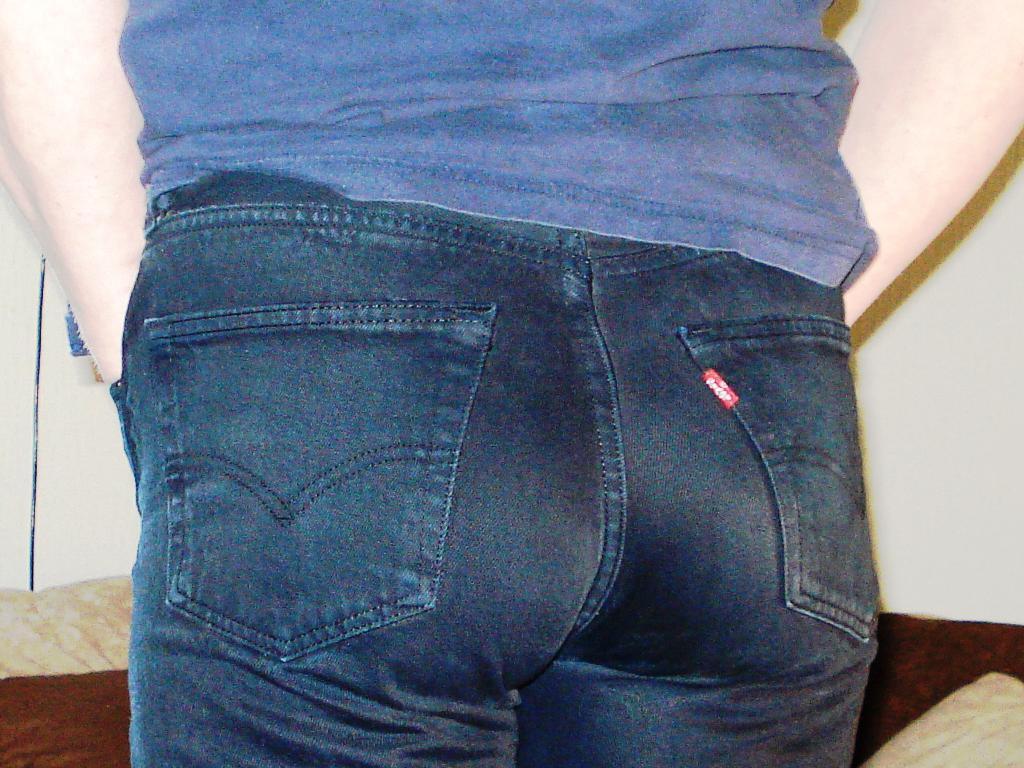In one or two sentences, can you explain what this image depicts? In this picture we can see a person is standing on the path and in front of the person there is a wall. 